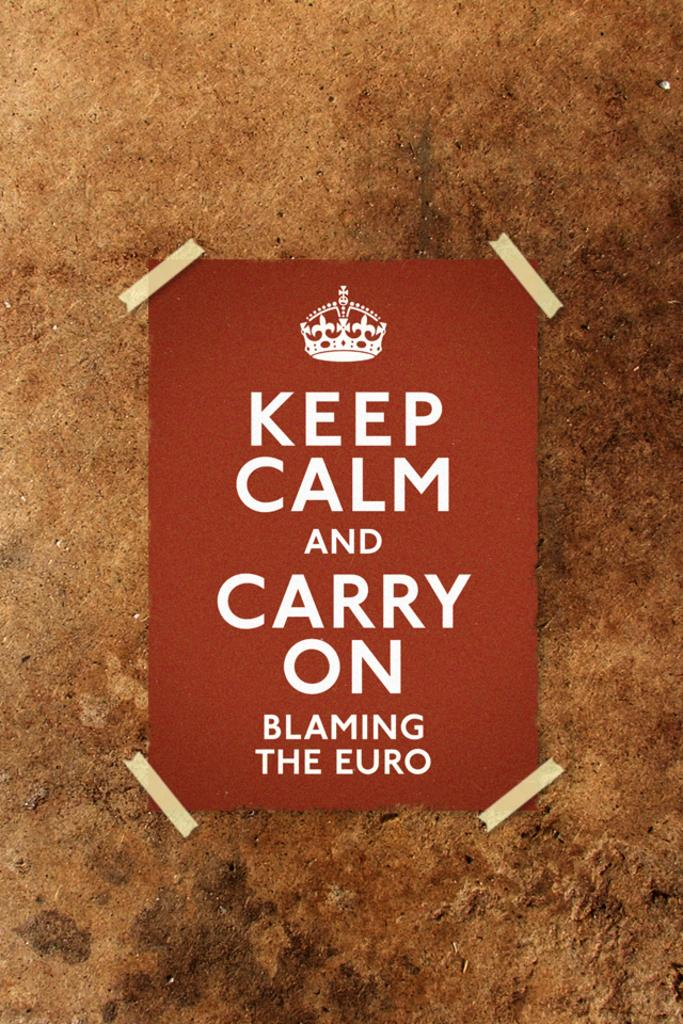<image>
Summarize the visual content of the image. a poster reading keep calm and carry on 